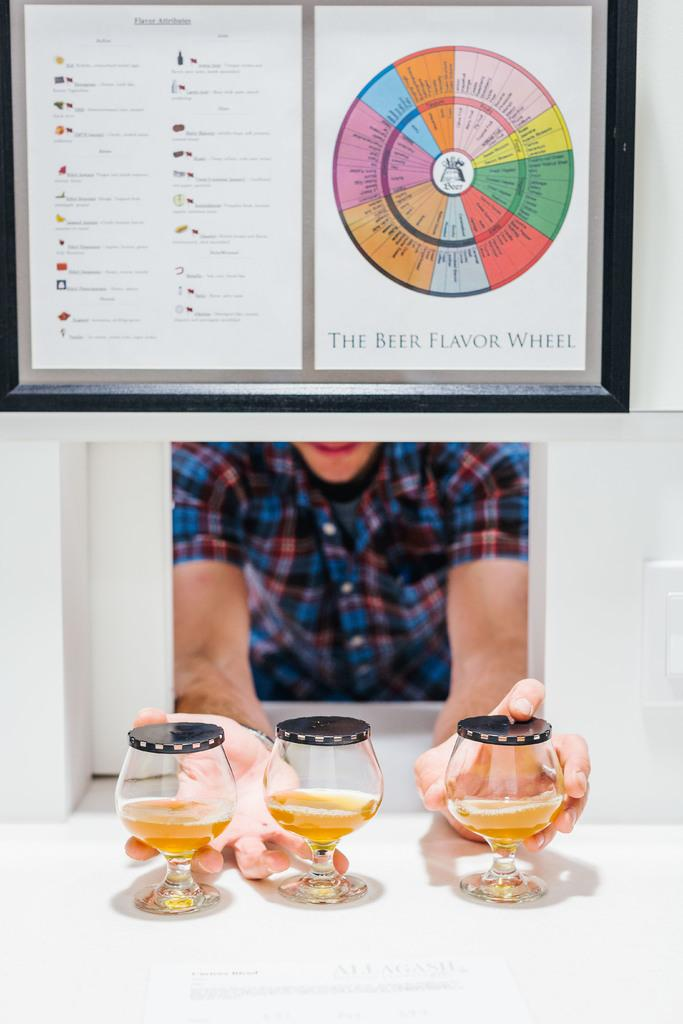What type of artwork is the image? The image is a collage. What can be found in one part of the collage? There is a circle with text in one part of the collage. What is depicted in another part of the collage? There is an image of a person holding glasses in another part of the collage. How many legs does the bulb have in the image? There is no bulb present in the image. 